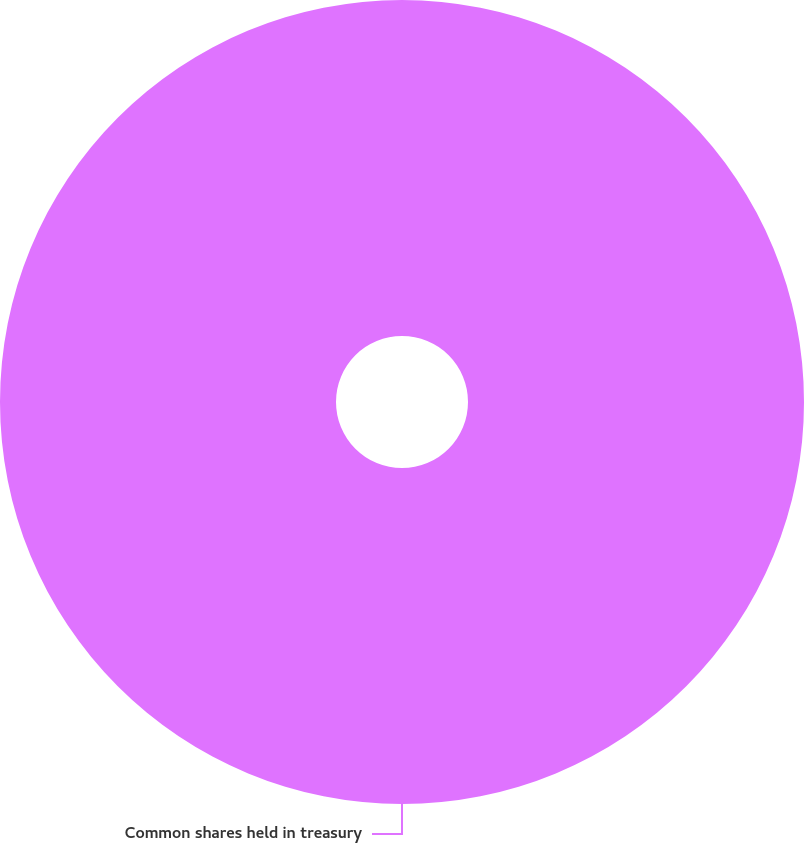Convert chart. <chart><loc_0><loc_0><loc_500><loc_500><pie_chart><fcel>Common shares held in treasury<nl><fcel>100.0%<nl></chart> 